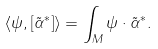<formula> <loc_0><loc_0><loc_500><loc_500>\langle \psi , [ \tilde { \alpha } ^ { * } ] \rangle = \int _ { M } \psi \cdot \tilde { \alpha } ^ { * } .</formula> 